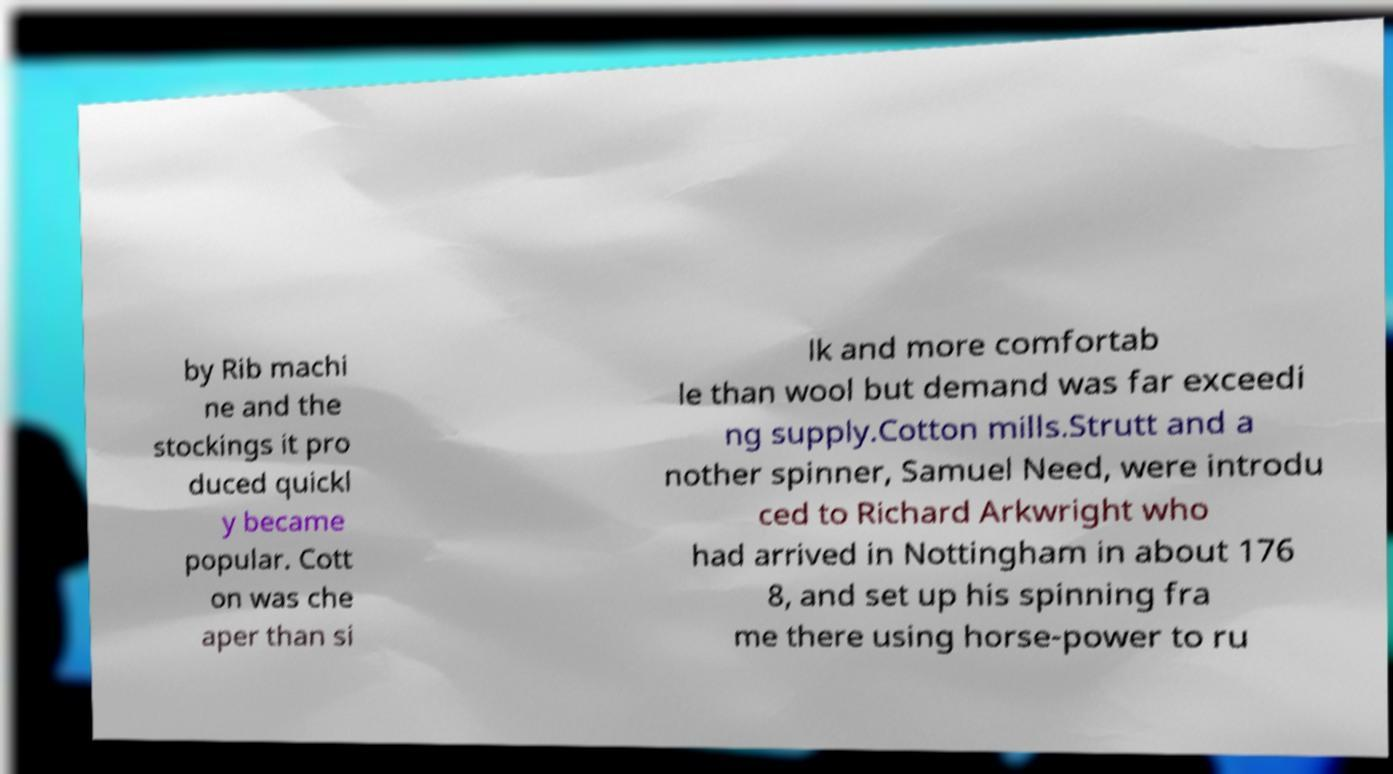Can you read and provide the text displayed in the image?This photo seems to have some interesting text. Can you extract and type it out for me? by Rib machi ne and the stockings it pro duced quickl y became popular. Cott on was che aper than si lk and more comfortab le than wool but demand was far exceedi ng supply.Cotton mills.Strutt and a nother spinner, Samuel Need, were introdu ced to Richard Arkwright who had arrived in Nottingham in about 176 8, and set up his spinning fra me there using horse-power to ru 